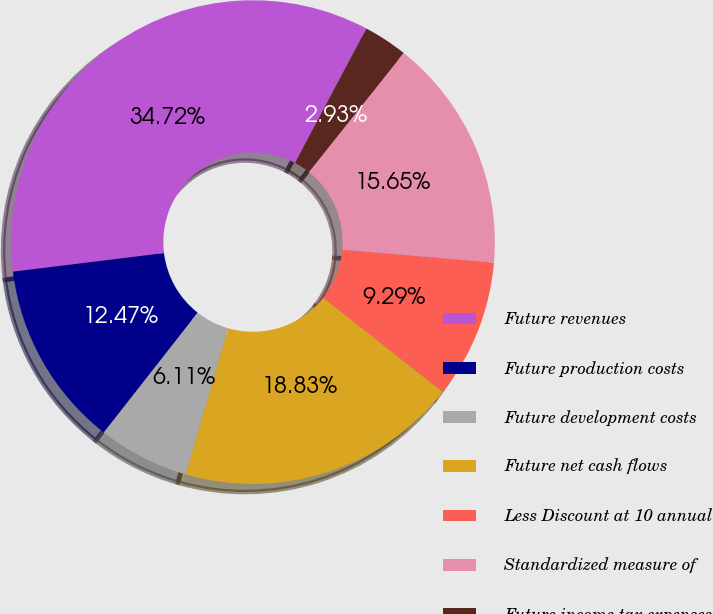<chart> <loc_0><loc_0><loc_500><loc_500><pie_chart><fcel>Future revenues<fcel>Future production costs<fcel>Future development costs<fcel>Future net cash flows<fcel>Less Discount at 10 annual<fcel>Standardized measure of<fcel>Future income tax expenses<nl><fcel>34.72%<fcel>12.47%<fcel>6.11%<fcel>18.83%<fcel>9.29%<fcel>15.65%<fcel>2.93%<nl></chart> 